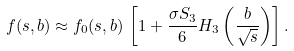Convert formula to latex. <formula><loc_0><loc_0><loc_500><loc_500>f ( s , b ) \approx f _ { 0 } ( s , b ) \, \left [ 1 + \frac { \sigma S _ { 3 } } { 6 } H _ { 3 } \left ( \frac { b } { \sqrt { s } } \right ) \right ] .</formula> 